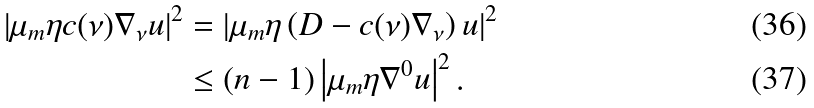<formula> <loc_0><loc_0><loc_500><loc_500>\left | \mu _ { m } \eta c ( \nu ) \nabla _ { \nu } u \right | ^ { 2 } & = \left | \mu _ { m } \eta \left ( D - c ( \nu ) \nabla _ { \nu } \right ) u \right | ^ { 2 } \\ & \leq ( n - 1 ) \left | \mu _ { m } \eta \nabla ^ { 0 } u \right | ^ { 2 } .</formula> 